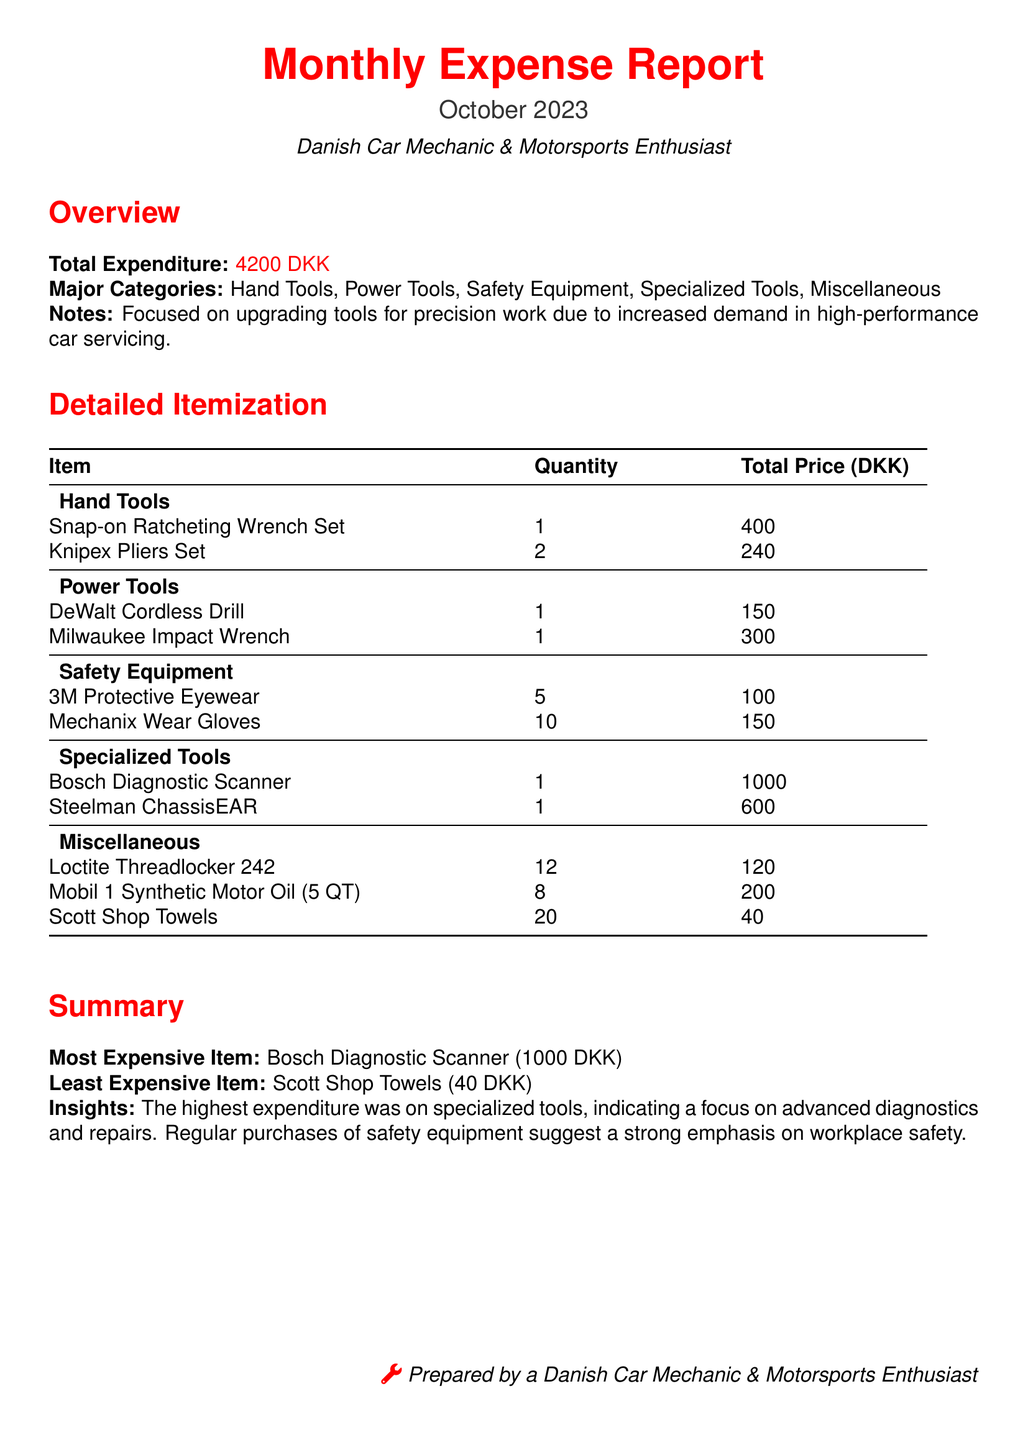what is the total expenditure? The total expenditure is listed in the overview section of the report as 4200 DKK.
Answer: 4200 DKK what is the most expensive item? The most expensive item is specified in the summary section of the document, which states Bosch Diagnostic Scanner.
Answer: Bosch Diagnostic Scanner how many items are there in the Safety Equipment category? The Safety Equipment category lists 2 item entries: 3M Protective Eyewear and Mechanix Wear Gloves.
Answer: 2 what is the quantity of Snap-on Ratcheting Wrench Sets purchased? The quantity of Snap-on Ratcheting Wrench Sets is provided in the detailed itemization, showing 1 set was purchased.
Answer: 1 how much did the Milwaukee Impact Wrench cost? The total price for the Milwaukee Impact Wrench is detailed in the itemization as 300 DKK.
Answer: 300 DKK what category does the item with the least cost fall under? The item with the least cost is Scott Shop Towels, which is categorized under Miscellaneous.
Answer: Miscellaneous what was the total cost of the Knipex Pliers Set? The total price for the Knipex Pliers Set is indicated in the document as 240 DKK for 2 sets.
Answer: 240 DKK which category had the highest expenditure? The insights section summarizes that specialized tools had the highest expenditure.
Answer: Specialized Tools 